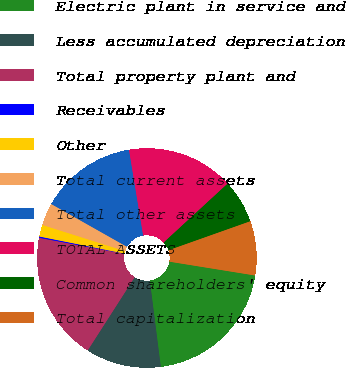Convert chart. <chart><loc_0><loc_0><loc_500><loc_500><pie_chart><fcel>Electric plant in service and<fcel>Less accumulated depreciation<fcel>Total property plant and<fcel>Receivables<fcel>Other<fcel>Total current assets<fcel>Total other assets<fcel>TOTAL ASSETS<fcel>Common shareholders' equity<fcel>Total capitalization<nl><fcel>20.44%<fcel>11.09%<fcel>18.88%<fcel>0.19%<fcel>1.74%<fcel>3.3%<fcel>14.21%<fcel>15.76%<fcel>6.42%<fcel>7.97%<nl></chart> 